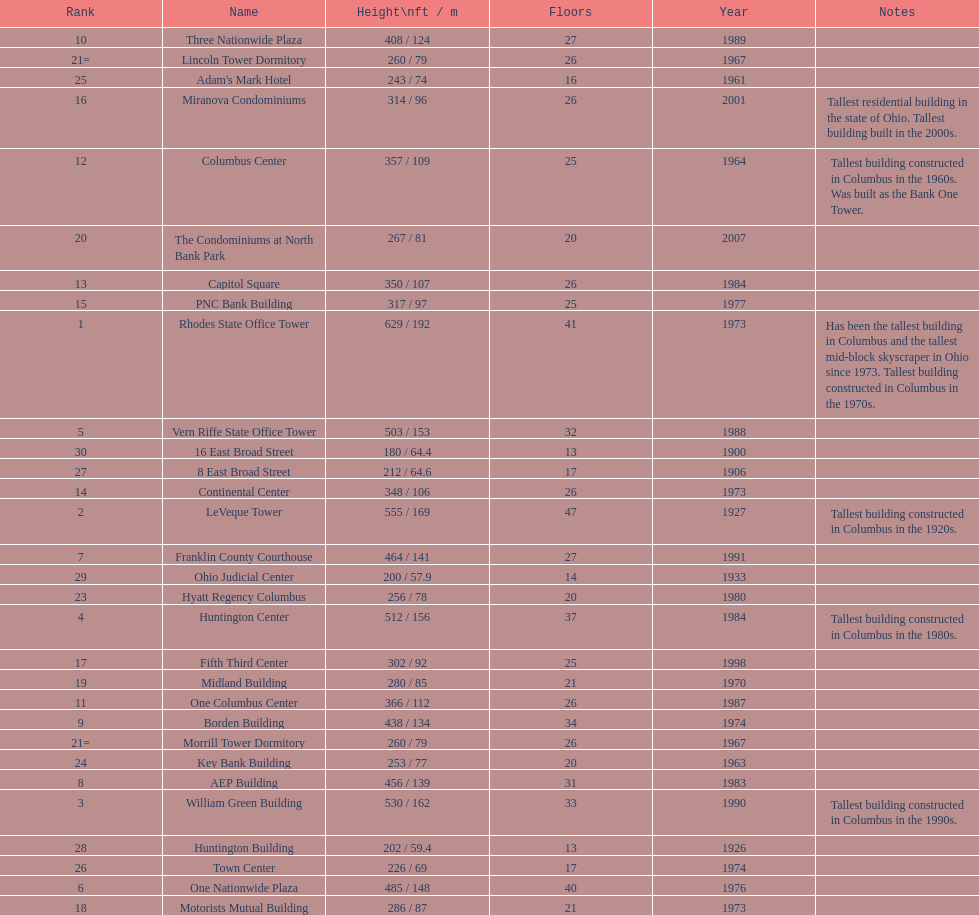How tall is the aep building? 456 / 139. Could you parse the entire table as a dict? {'header': ['Rank', 'Name', 'Height\\nft / m', 'Floors', 'Year', 'Notes'], 'rows': [['10', 'Three Nationwide Plaza', '408 / 124', '27', '1989', ''], ['21=', 'Lincoln Tower Dormitory', '260 / 79', '26', '1967', ''], ['25', "Adam's Mark Hotel", '243 / 74', '16', '1961', ''], ['16', 'Miranova Condominiums', '314 / 96', '26', '2001', 'Tallest residential building in the state of Ohio. Tallest building built in the 2000s.'], ['12', 'Columbus Center', '357 / 109', '25', '1964', 'Tallest building constructed in Columbus in the 1960s. Was built as the Bank One Tower.'], ['20', 'The Condominiums at North Bank Park', '267 / 81', '20', '2007', ''], ['13', 'Capitol Square', '350 / 107', '26', '1984', ''], ['15', 'PNC Bank Building', '317 / 97', '25', '1977', ''], ['1', 'Rhodes State Office Tower', '629 / 192', '41', '1973', 'Has been the tallest building in Columbus and the tallest mid-block skyscraper in Ohio since 1973. Tallest building constructed in Columbus in the 1970s.'], ['5', 'Vern Riffe State Office Tower', '503 / 153', '32', '1988', ''], ['30', '16 East Broad Street', '180 / 64.4', '13', '1900', ''], ['27', '8 East Broad Street', '212 / 64.6', '17', '1906', ''], ['14', 'Continental Center', '348 / 106', '26', '1973', ''], ['2', 'LeVeque Tower', '555 / 169', '47', '1927', 'Tallest building constructed in Columbus in the 1920s.'], ['7', 'Franklin County Courthouse', '464 / 141', '27', '1991', ''], ['29', 'Ohio Judicial Center', '200 / 57.9', '14', '1933', ''], ['23', 'Hyatt Regency Columbus', '256 / 78', '20', '1980', ''], ['4', 'Huntington Center', '512 / 156', '37', '1984', 'Tallest building constructed in Columbus in the 1980s.'], ['17', 'Fifth Third Center', '302 / 92', '25', '1998', ''], ['19', 'Midland Building', '280 / 85', '21', '1970', ''], ['11', 'One Columbus Center', '366 / 112', '26', '1987', ''], ['9', 'Borden Building', '438 / 134', '34', '1974', ''], ['21=', 'Morrill Tower Dormitory', '260 / 79', '26', '1967', ''], ['24', 'Key Bank Building', '253 / 77', '20', '1963', ''], ['8', 'AEP Building', '456 / 139', '31', '1983', ''], ['3', 'William Green Building', '530 / 162', '33', '1990', 'Tallest building constructed in Columbus in the 1990s.'], ['28', 'Huntington Building', '202 / 59.4', '13', '1926', ''], ['26', 'Town Center', '226 / 69', '17', '1974', ''], ['6', 'One Nationwide Plaza', '485 / 148', '40', '1976', ''], ['18', 'Motorists Mutual Building', '286 / 87', '21', '1973', '']]} How tall is the one columbus center? 366 / 112. Of these two buildings, which is taller? AEP Building. 